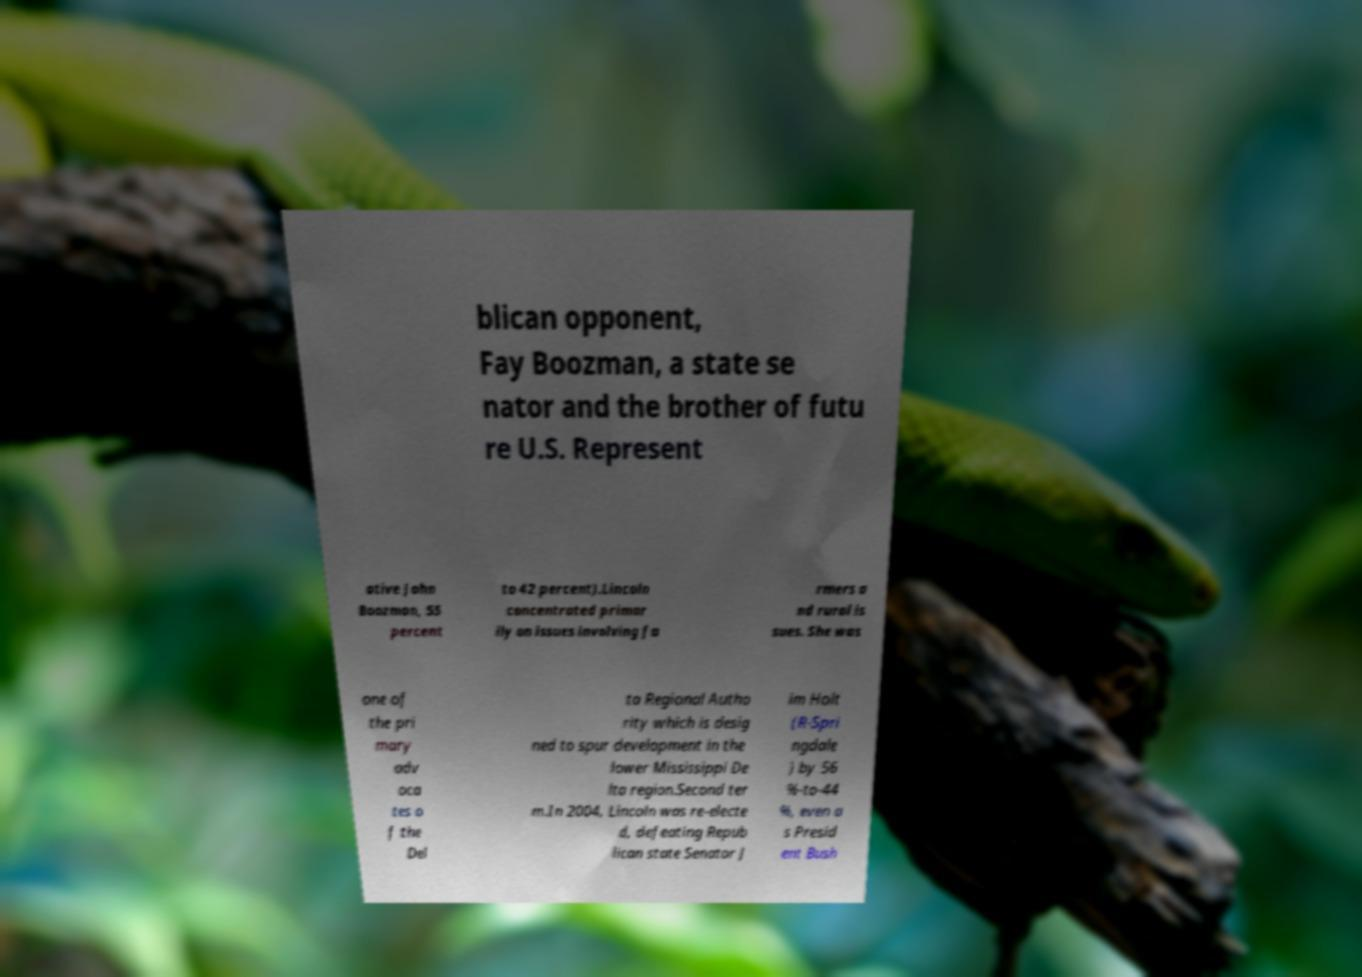Please identify and transcribe the text found in this image. blican opponent, Fay Boozman, a state se nator and the brother of futu re U.S. Represent ative John Boozman, 55 percent to 42 percent).Lincoln concentrated primar ily on issues involving fa rmers a nd rural is sues. She was one of the pri mary adv oca tes o f the Del ta Regional Autho rity which is desig ned to spur development in the lower Mississippi De lta region.Second ter m.In 2004, Lincoln was re-electe d, defeating Repub lican state Senator J im Holt (R-Spri ngdale ) by 56 %-to-44 %, even a s Presid ent Bush 